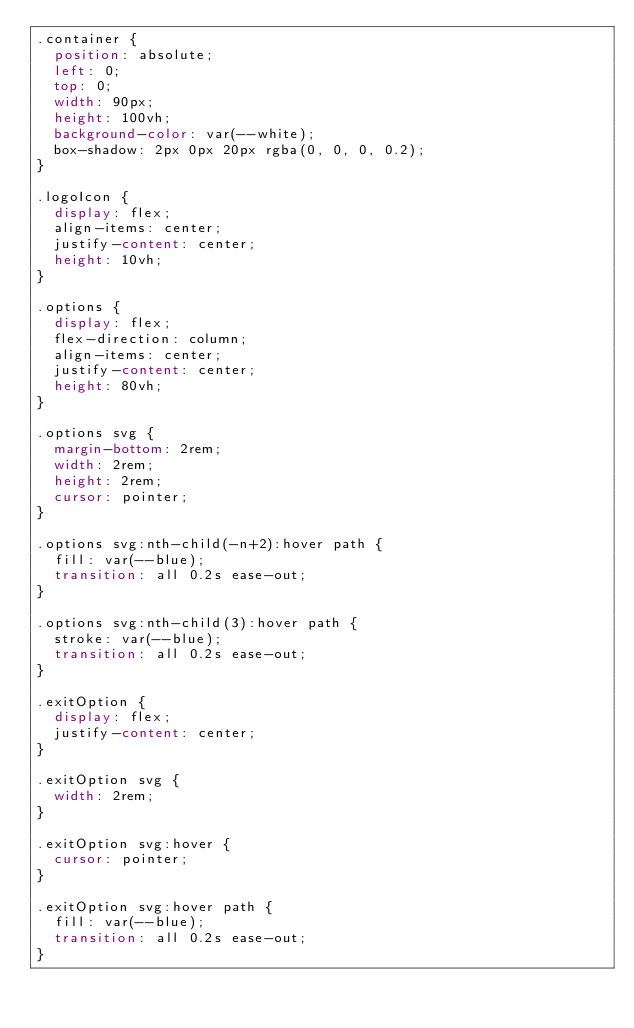<code> <loc_0><loc_0><loc_500><loc_500><_CSS_>.container {
  position: absolute;
  left: 0;
  top: 0;
  width: 90px;
  height: 100vh;
  background-color: var(--white);
  box-shadow: 2px 0px 20px rgba(0, 0, 0, 0.2);
}

.logoIcon {
  display: flex;
  align-items: center;
  justify-content: center;
  height: 10vh;
}

.options {
  display: flex;
  flex-direction: column;
  align-items: center;
  justify-content: center;
  height: 80vh;
}

.options svg {
  margin-bottom: 2rem;
  width: 2rem;
  height: 2rem;
  cursor: pointer;
}

.options svg:nth-child(-n+2):hover path {
  fill: var(--blue);
  transition: all 0.2s ease-out;
}

.options svg:nth-child(3):hover path {
  stroke: var(--blue);
  transition: all 0.2s ease-out;
}

.exitOption {
  display: flex;
  justify-content: center;
}

.exitOption svg {
  width: 2rem;
}

.exitOption svg:hover {
  cursor: pointer;
}

.exitOption svg:hover path {
  fill: var(--blue);
  transition: all 0.2s ease-out;
}</code> 